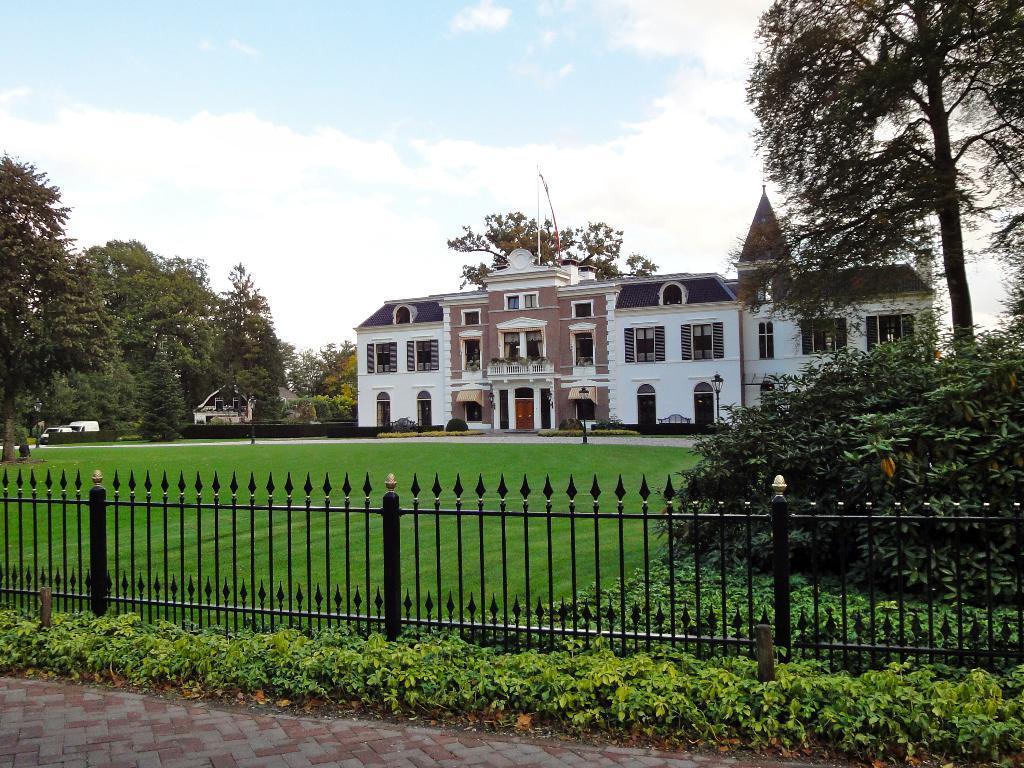Can you describe this image briefly? In this picture I can see buildings, there are plants, iron grilles, there are trees, and in the background there is the sky. 